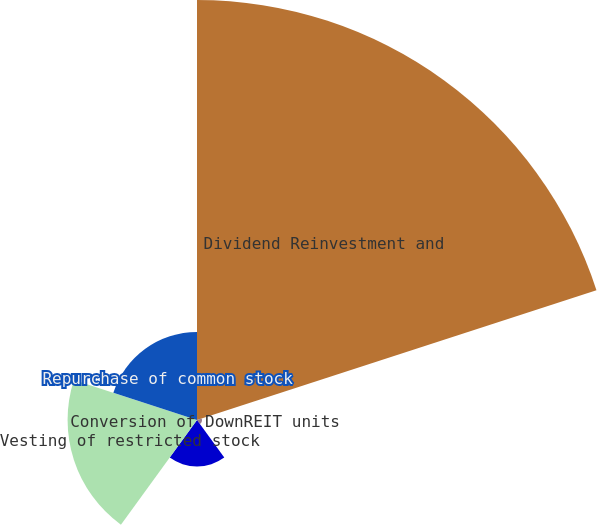Convert chart. <chart><loc_0><loc_0><loc_500><loc_500><pie_chart><fcel>Dividend Reinvestment and<fcel>Conversion of DownREIT units<fcel>Exercise of stock options<fcel>Vesting of restricted stock<fcel>Repurchase of common stock<nl><fcel>60.98%<fcel>0.72%<fcel>6.74%<fcel>18.79%<fcel>12.77%<nl></chart> 